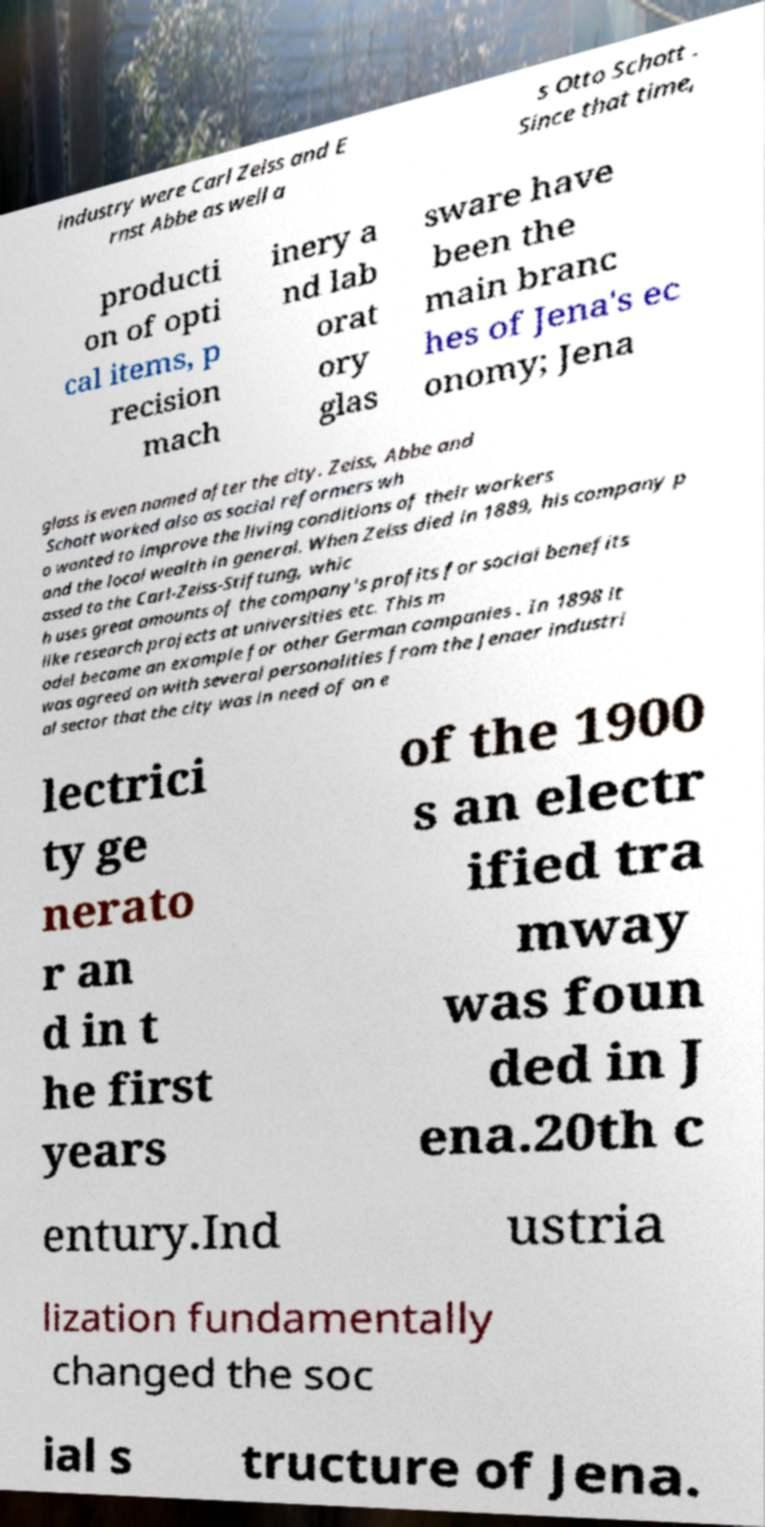Could you extract and type out the text from this image? industry were Carl Zeiss and E rnst Abbe as well a s Otto Schott . Since that time, producti on of opti cal items, p recision mach inery a nd lab orat ory glas sware have been the main branc hes of Jena's ec onomy; Jena glass is even named after the city. Zeiss, Abbe and Schott worked also as social reformers wh o wanted to improve the living conditions of their workers and the local wealth in general. When Zeiss died in 1889, his company p assed to the Carl-Zeiss-Stiftung, whic h uses great amounts of the company's profits for social benefits like research projects at universities etc. This m odel became an example for other German companies . In 1898 it was agreed on with several personalities from the Jenaer industri al sector that the city was in need of an e lectrici ty ge nerato r an d in t he first years of the 1900 s an electr ified tra mway was foun ded in J ena.20th c entury.Ind ustria lization fundamentally changed the soc ial s tructure of Jena. 